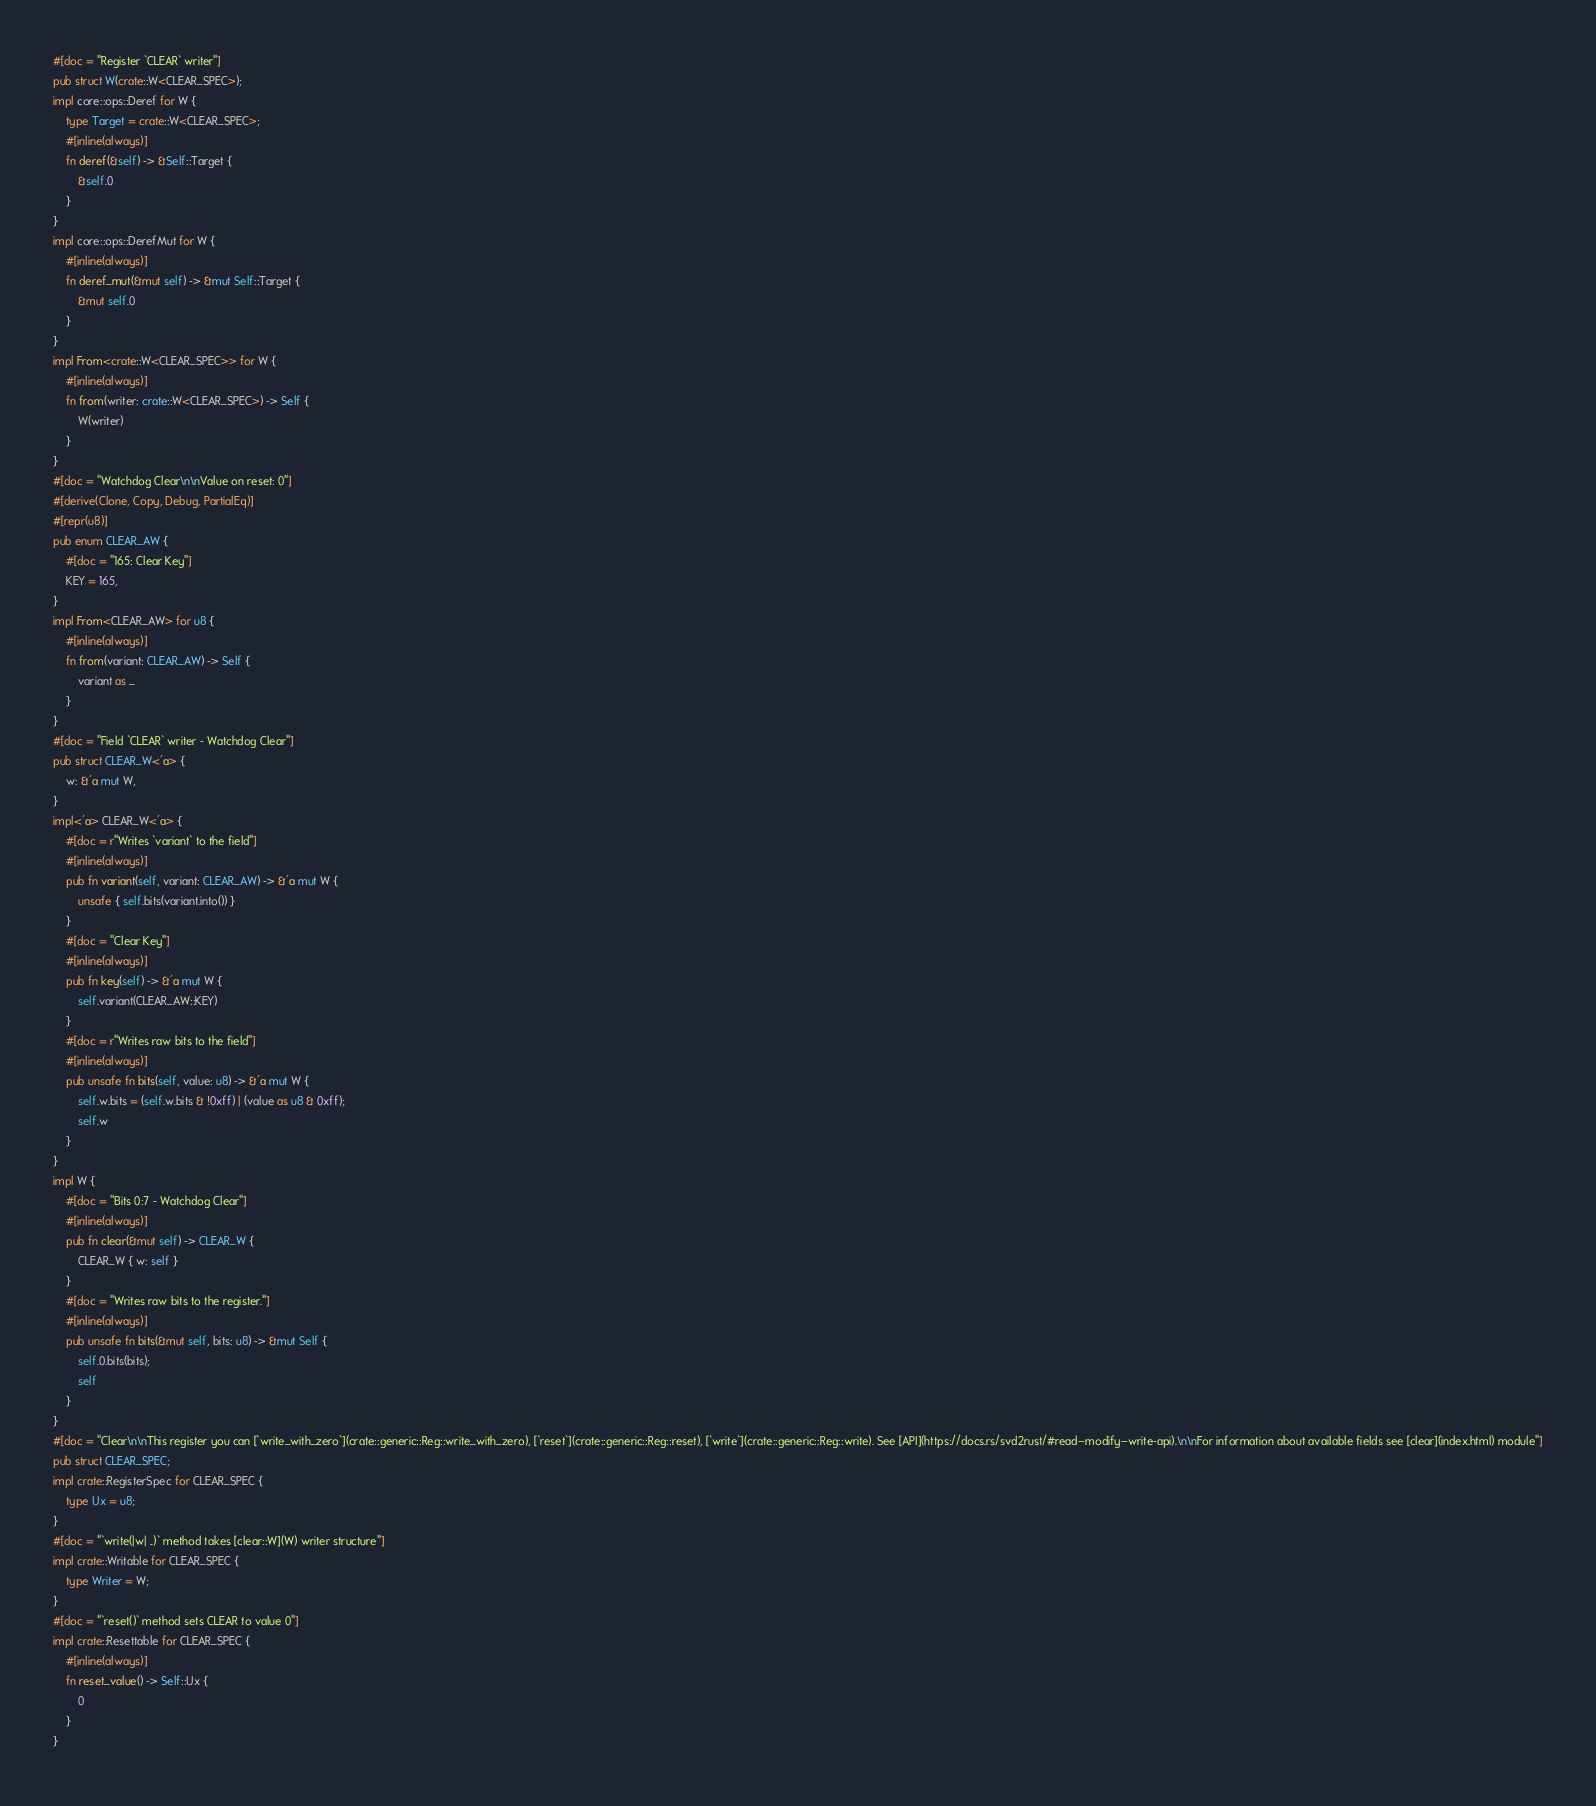Convert code to text. <code><loc_0><loc_0><loc_500><loc_500><_Rust_>#[doc = "Register `CLEAR` writer"]
pub struct W(crate::W<CLEAR_SPEC>);
impl core::ops::Deref for W {
    type Target = crate::W<CLEAR_SPEC>;
    #[inline(always)]
    fn deref(&self) -> &Self::Target {
        &self.0
    }
}
impl core::ops::DerefMut for W {
    #[inline(always)]
    fn deref_mut(&mut self) -> &mut Self::Target {
        &mut self.0
    }
}
impl From<crate::W<CLEAR_SPEC>> for W {
    #[inline(always)]
    fn from(writer: crate::W<CLEAR_SPEC>) -> Self {
        W(writer)
    }
}
#[doc = "Watchdog Clear\n\nValue on reset: 0"]
#[derive(Clone, Copy, Debug, PartialEq)]
#[repr(u8)]
pub enum CLEAR_AW {
    #[doc = "165: Clear Key"]
    KEY = 165,
}
impl From<CLEAR_AW> for u8 {
    #[inline(always)]
    fn from(variant: CLEAR_AW) -> Self {
        variant as _
    }
}
#[doc = "Field `CLEAR` writer - Watchdog Clear"]
pub struct CLEAR_W<'a> {
    w: &'a mut W,
}
impl<'a> CLEAR_W<'a> {
    #[doc = r"Writes `variant` to the field"]
    #[inline(always)]
    pub fn variant(self, variant: CLEAR_AW) -> &'a mut W {
        unsafe { self.bits(variant.into()) }
    }
    #[doc = "Clear Key"]
    #[inline(always)]
    pub fn key(self) -> &'a mut W {
        self.variant(CLEAR_AW::KEY)
    }
    #[doc = r"Writes raw bits to the field"]
    #[inline(always)]
    pub unsafe fn bits(self, value: u8) -> &'a mut W {
        self.w.bits = (self.w.bits & !0xff) | (value as u8 & 0xff);
        self.w
    }
}
impl W {
    #[doc = "Bits 0:7 - Watchdog Clear"]
    #[inline(always)]
    pub fn clear(&mut self) -> CLEAR_W {
        CLEAR_W { w: self }
    }
    #[doc = "Writes raw bits to the register."]
    #[inline(always)]
    pub unsafe fn bits(&mut self, bits: u8) -> &mut Self {
        self.0.bits(bits);
        self
    }
}
#[doc = "Clear\n\nThis register you can [`write_with_zero`](crate::generic::Reg::write_with_zero), [`reset`](crate::generic::Reg::reset), [`write`](crate::generic::Reg::write). See [API](https://docs.rs/svd2rust/#read--modify--write-api).\n\nFor information about available fields see [clear](index.html) module"]
pub struct CLEAR_SPEC;
impl crate::RegisterSpec for CLEAR_SPEC {
    type Ux = u8;
}
#[doc = "`write(|w| ..)` method takes [clear::W](W) writer structure"]
impl crate::Writable for CLEAR_SPEC {
    type Writer = W;
}
#[doc = "`reset()` method sets CLEAR to value 0"]
impl crate::Resettable for CLEAR_SPEC {
    #[inline(always)]
    fn reset_value() -> Self::Ux {
        0
    }
}
</code> 